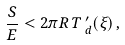Convert formula to latex. <formula><loc_0><loc_0><loc_500><loc_500>\frac { S } { E } < 2 \pi R \, T \, ^ { \prime } _ { d } ( \xi ) \, ,</formula> 